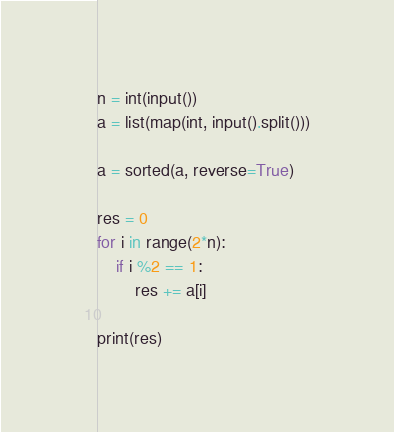Convert code to text. <code><loc_0><loc_0><loc_500><loc_500><_Python_>n = int(input())
a = list(map(int, input().split()))

a = sorted(a, reverse=True)

res = 0
for i in range(2*n):
	if i %2 == 1:
		res += a[i]

print(res)</code> 